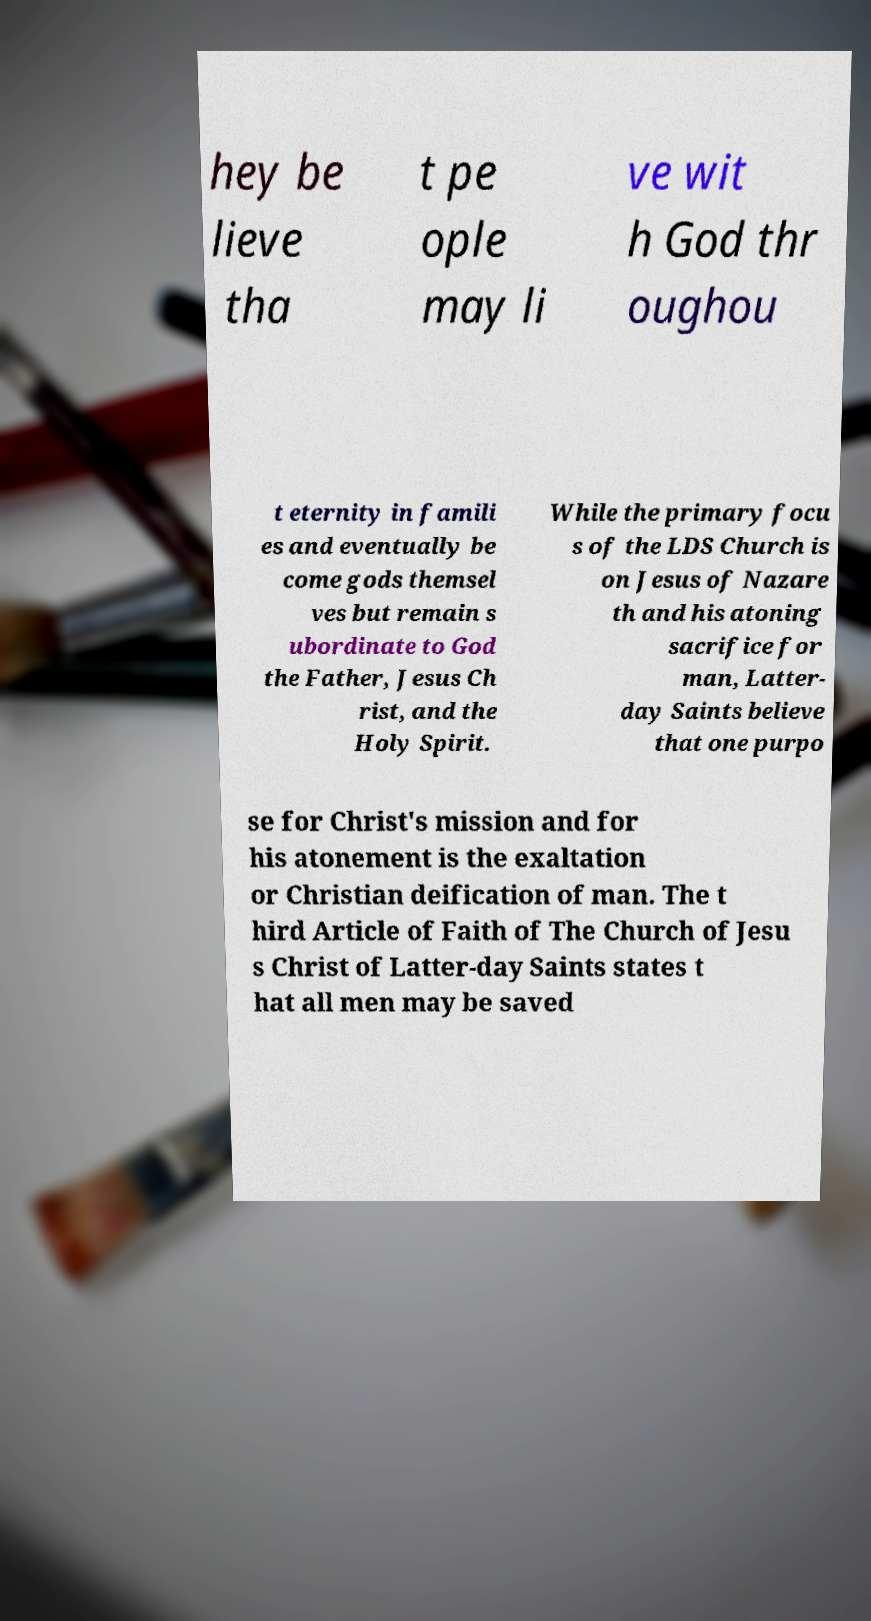Could you assist in decoding the text presented in this image and type it out clearly? hey be lieve tha t pe ople may li ve wit h God thr oughou t eternity in famili es and eventually be come gods themsel ves but remain s ubordinate to God the Father, Jesus Ch rist, and the Holy Spirit. While the primary focu s of the LDS Church is on Jesus of Nazare th and his atoning sacrifice for man, Latter- day Saints believe that one purpo se for Christ's mission and for his atonement is the exaltation or Christian deification of man. The t hird Article of Faith of The Church of Jesu s Christ of Latter-day Saints states t hat all men may be saved 